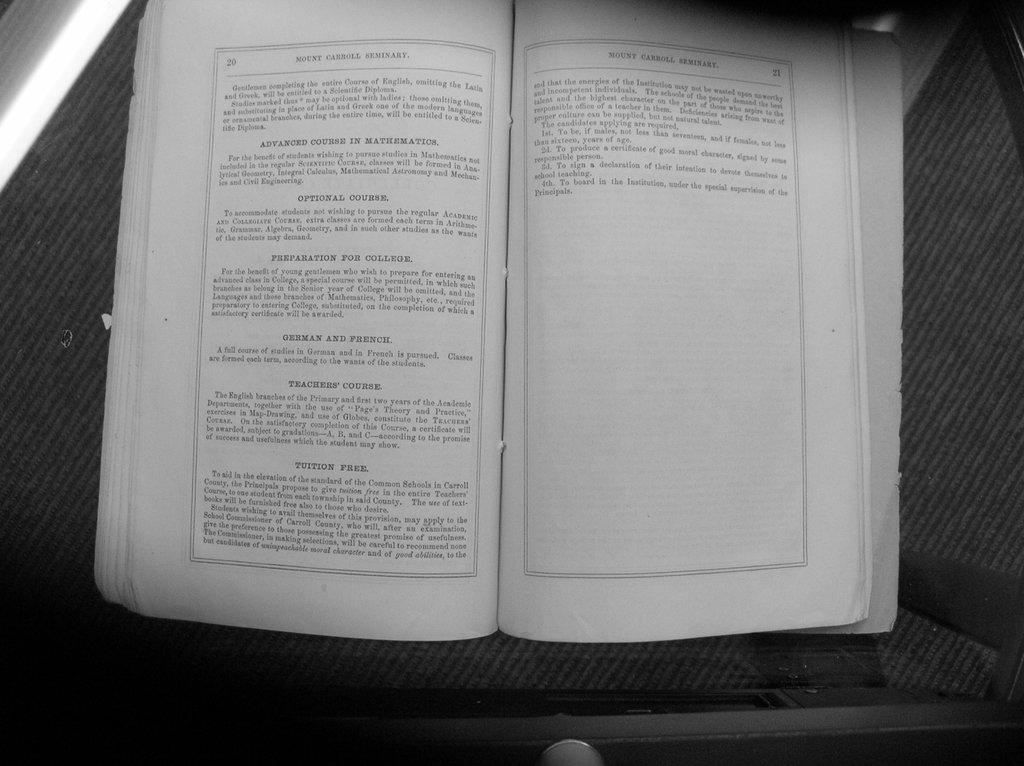<image>
Offer a succinct explanation of the picture presented. An open book with the words Mount Carroll Seminary on top 